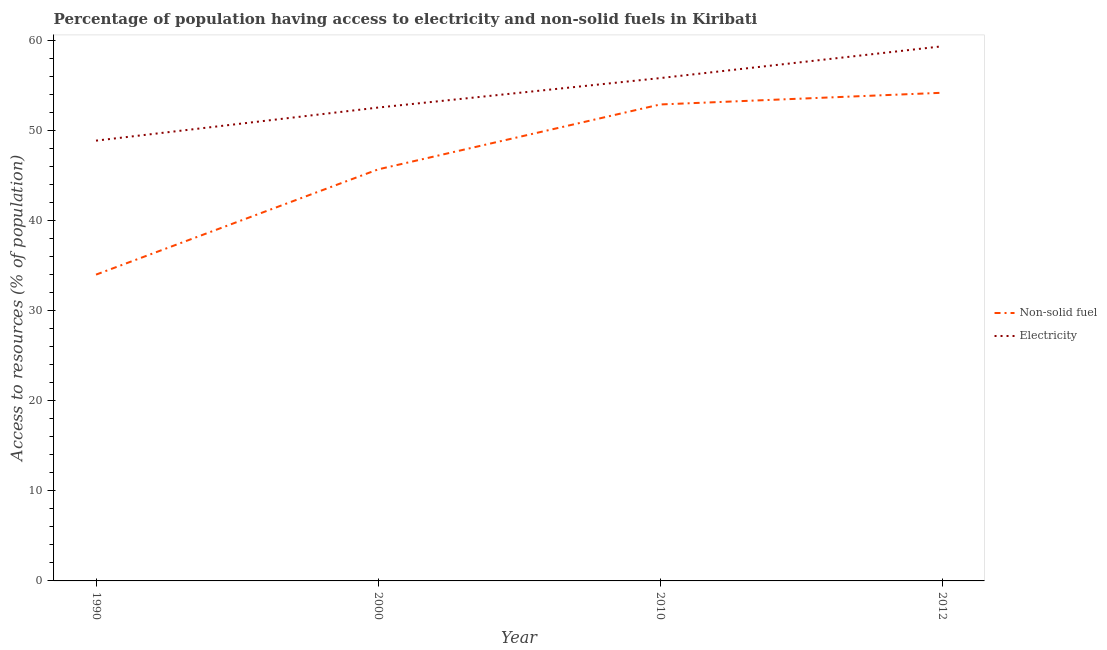What is the percentage of population having access to electricity in 2010?
Your response must be concise. 55.8. Across all years, what is the maximum percentage of population having access to non-solid fuel?
Ensure brevity in your answer.  54.17. Across all years, what is the minimum percentage of population having access to non-solid fuel?
Keep it short and to the point. 33.99. In which year was the percentage of population having access to electricity maximum?
Give a very brief answer. 2012. What is the total percentage of population having access to non-solid fuel in the graph?
Offer a terse response. 186.7. What is the difference between the percentage of population having access to electricity in 1990 and that in 2000?
Provide a short and direct response. -3.67. What is the difference between the percentage of population having access to electricity in 1990 and the percentage of population having access to non-solid fuel in 2000?
Provide a short and direct response. 3.19. What is the average percentage of population having access to non-solid fuel per year?
Ensure brevity in your answer.  46.68. In the year 2012, what is the difference between the percentage of population having access to non-solid fuel and percentage of population having access to electricity?
Your answer should be very brief. -5.16. What is the ratio of the percentage of population having access to non-solid fuel in 2010 to that in 2012?
Offer a very short reply. 0.98. Is the percentage of population having access to electricity in 1990 less than that in 2010?
Offer a very short reply. Yes. Is the difference between the percentage of population having access to electricity in 1990 and 2012 greater than the difference between the percentage of population having access to non-solid fuel in 1990 and 2012?
Your response must be concise. Yes. What is the difference between the highest and the second highest percentage of population having access to non-solid fuel?
Give a very brief answer. 1.3. What is the difference between the highest and the lowest percentage of population having access to non-solid fuel?
Your response must be concise. 20.18. In how many years, is the percentage of population having access to non-solid fuel greater than the average percentage of population having access to non-solid fuel taken over all years?
Ensure brevity in your answer.  2. Is the sum of the percentage of population having access to non-solid fuel in 2000 and 2012 greater than the maximum percentage of population having access to electricity across all years?
Make the answer very short. Yes. Does the percentage of population having access to electricity monotonically increase over the years?
Give a very brief answer. Yes. Is the percentage of population having access to non-solid fuel strictly greater than the percentage of population having access to electricity over the years?
Give a very brief answer. No. How many years are there in the graph?
Offer a very short reply. 4. What is the difference between two consecutive major ticks on the Y-axis?
Give a very brief answer. 10. Are the values on the major ticks of Y-axis written in scientific E-notation?
Offer a very short reply. No. Does the graph contain any zero values?
Make the answer very short. No. Does the graph contain grids?
Keep it short and to the point. No. How many legend labels are there?
Give a very brief answer. 2. How are the legend labels stacked?
Offer a terse response. Vertical. What is the title of the graph?
Your answer should be compact. Percentage of population having access to electricity and non-solid fuels in Kiribati. What is the label or title of the Y-axis?
Ensure brevity in your answer.  Access to resources (% of population). What is the Access to resources (% of population) of Non-solid fuel in 1990?
Offer a very short reply. 33.99. What is the Access to resources (% of population) in Electricity in 1990?
Offer a very short reply. 48.86. What is the Access to resources (% of population) of Non-solid fuel in 2000?
Provide a succinct answer. 45.67. What is the Access to resources (% of population) in Electricity in 2000?
Your answer should be compact. 52.53. What is the Access to resources (% of population) of Non-solid fuel in 2010?
Offer a terse response. 52.87. What is the Access to resources (% of population) in Electricity in 2010?
Offer a very short reply. 55.8. What is the Access to resources (% of population) of Non-solid fuel in 2012?
Ensure brevity in your answer.  54.17. What is the Access to resources (% of population) in Electricity in 2012?
Provide a succinct answer. 59.33. Across all years, what is the maximum Access to resources (% of population) of Non-solid fuel?
Keep it short and to the point. 54.17. Across all years, what is the maximum Access to resources (% of population) of Electricity?
Your answer should be very brief. 59.33. Across all years, what is the minimum Access to resources (% of population) in Non-solid fuel?
Your response must be concise. 33.99. Across all years, what is the minimum Access to resources (% of population) of Electricity?
Give a very brief answer. 48.86. What is the total Access to resources (% of population) in Non-solid fuel in the graph?
Your answer should be compact. 186.7. What is the total Access to resources (% of population) in Electricity in the graph?
Ensure brevity in your answer.  216.52. What is the difference between the Access to resources (% of population) of Non-solid fuel in 1990 and that in 2000?
Offer a terse response. -11.68. What is the difference between the Access to resources (% of population) in Electricity in 1990 and that in 2000?
Give a very brief answer. -3.67. What is the difference between the Access to resources (% of population) of Non-solid fuel in 1990 and that in 2010?
Your response must be concise. -18.88. What is the difference between the Access to resources (% of population) of Electricity in 1990 and that in 2010?
Give a very brief answer. -6.94. What is the difference between the Access to resources (% of population) of Non-solid fuel in 1990 and that in 2012?
Your answer should be compact. -20.18. What is the difference between the Access to resources (% of population) of Electricity in 1990 and that in 2012?
Ensure brevity in your answer.  -10.47. What is the difference between the Access to resources (% of population) of Non-solid fuel in 2000 and that in 2010?
Your response must be concise. -7.2. What is the difference between the Access to resources (% of population) of Electricity in 2000 and that in 2010?
Provide a succinct answer. -3.27. What is the difference between the Access to resources (% of population) in Non-solid fuel in 2000 and that in 2012?
Ensure brevity in your answer.  -8.5. What is the difference between the Access to resources (% of population) in Electricity in 2000 and that in 2012?
Make the answer very short. -6.8. What is the difference between the Access to resources (% of population) in Electricity in 2010 and that in 2012?
Offer a terse response. -3.53. What is the difference between the Access to resources (% of population) in Non-solid fuel in 1990 and the Access to resources (% of population) in Electricity in 2000?
Your answer should be very brief. -18.54. What is the difference between the Access to resources (% of population) of Non-solid fuel in 1990 and the Access to resources (% of population) of Electricity in 2010?
Your answer should be compact. -21.81. What is the difference between the Access to resources (% of population) in Non-solid fuel in 1990 and the Access to resources (% of population) in Electricity in 2012?
Offer a terse response. -25.34. What is the difference between the Access to resources (% of population) in Non-solid fuel in 2000 and the Access to resources (% of population) in Electricity in 2010?
Your response must be concise. -10.13. What is the difference between the Access to resources (% of population) of Non-solid fuel in 2000 and the Access to resources (% of population) of Electricity in 2012?
Offer a terse response. -13.66. What is the difference between the Access to resources (% of population) in Non-solid fuel in 2010 and the Access to resources (% of population) in Electricity in 2012?
Make the answer very short. -6.46. What is the average Access to resources (% of population) in Non-solid fuel per year?
Ensure brevity in your answer.  46.68. What is the average Access to resources (% of population) in Electricity per year?
Offer a very short reply. 54.13. In the year 1990, what is the difference between the Access to resources (% of population) of Non-solid fuel and Access to resources (% of population) of Electricity?
Make the answer very short. -14.87. In the year 2000, what is the difference between the Access to resources (% of population) in Non-solid fuel and Access to resources (% of population) in Electricity?
Ensure brevity in your answer.  -6.86. In the year 2010, what is the difference between the Access to resources (% of population) in Non-solid fuel and Access to resources (% of population) in Electricity?
Your answer should be compact. -2.93. In the year 2012, what is the difference between the Access to resources (% of population) of Non-solid fuel and Access to resources (% of population) of Electricity?
Provide a short and direct response. -5.16. What is the ratio of the Access to resources (% of population) of Non-solid fuel in 1990 to that in 2000?
Your response must be concise. 0.74. What is the ratio of the Access to resources (% of population) in Electricity in 1990 to that in 2000?
Your answer should be compact. 0.93. What is the ratio of the Access to resources (% of population) of Non-solid fuel in 1990 to that in 2010?
Your answer should be compact. 0.64. What is the ratio of the Access to resources (% of population) of Electricity in 1990 to that in 2010?
Offer a terse response. 0.88. What is the ratio of the Access to resources (% of population) in Non-solid fuel in 1990 to that in 2012?
Provide a short and direct response. 0.63. What is the ratio of the Access to resources (% of population) in Electricity in 1990 to that in 2012?
Offer a terse response. 0.82. What is the ratio of the Access to resources (% of population) in Non-solid fuel in 2000 to that in 2010?
Ensure brevity in your answer.  0.86. What is the ratio of the Access to resources (% of population) of Electricity in 2000 to that in 2010?
Offer a very short reply. 0.94. What is the ratio of the Access to resources (% of population) in Non-solid fuel in 2000 to that in 2012?
Your answer should be very brief. 0.84. What is the ratio of the Access to resources (% of population) of Electricity in 2000 to that in 2012?
Offer a very short reply. 0.89. What is the ratio of the Access to resources (% of population) of Electricity in 2010 to that in 2012?
Give a very brief answer. 0.94. What is the difference between the highest and the second highest Access to resources (% of population) in Electricity?
Provide a succinct answer. 3.53. What is the difference between the highest and the lowest Access to resources (% of population) of Non-solid fuel?
Provide a short and direct response. 20.18. What is the difference between the highest and the lowest Access to resources (% of population) of Electricity?
Make the answer very short. 10.47. 